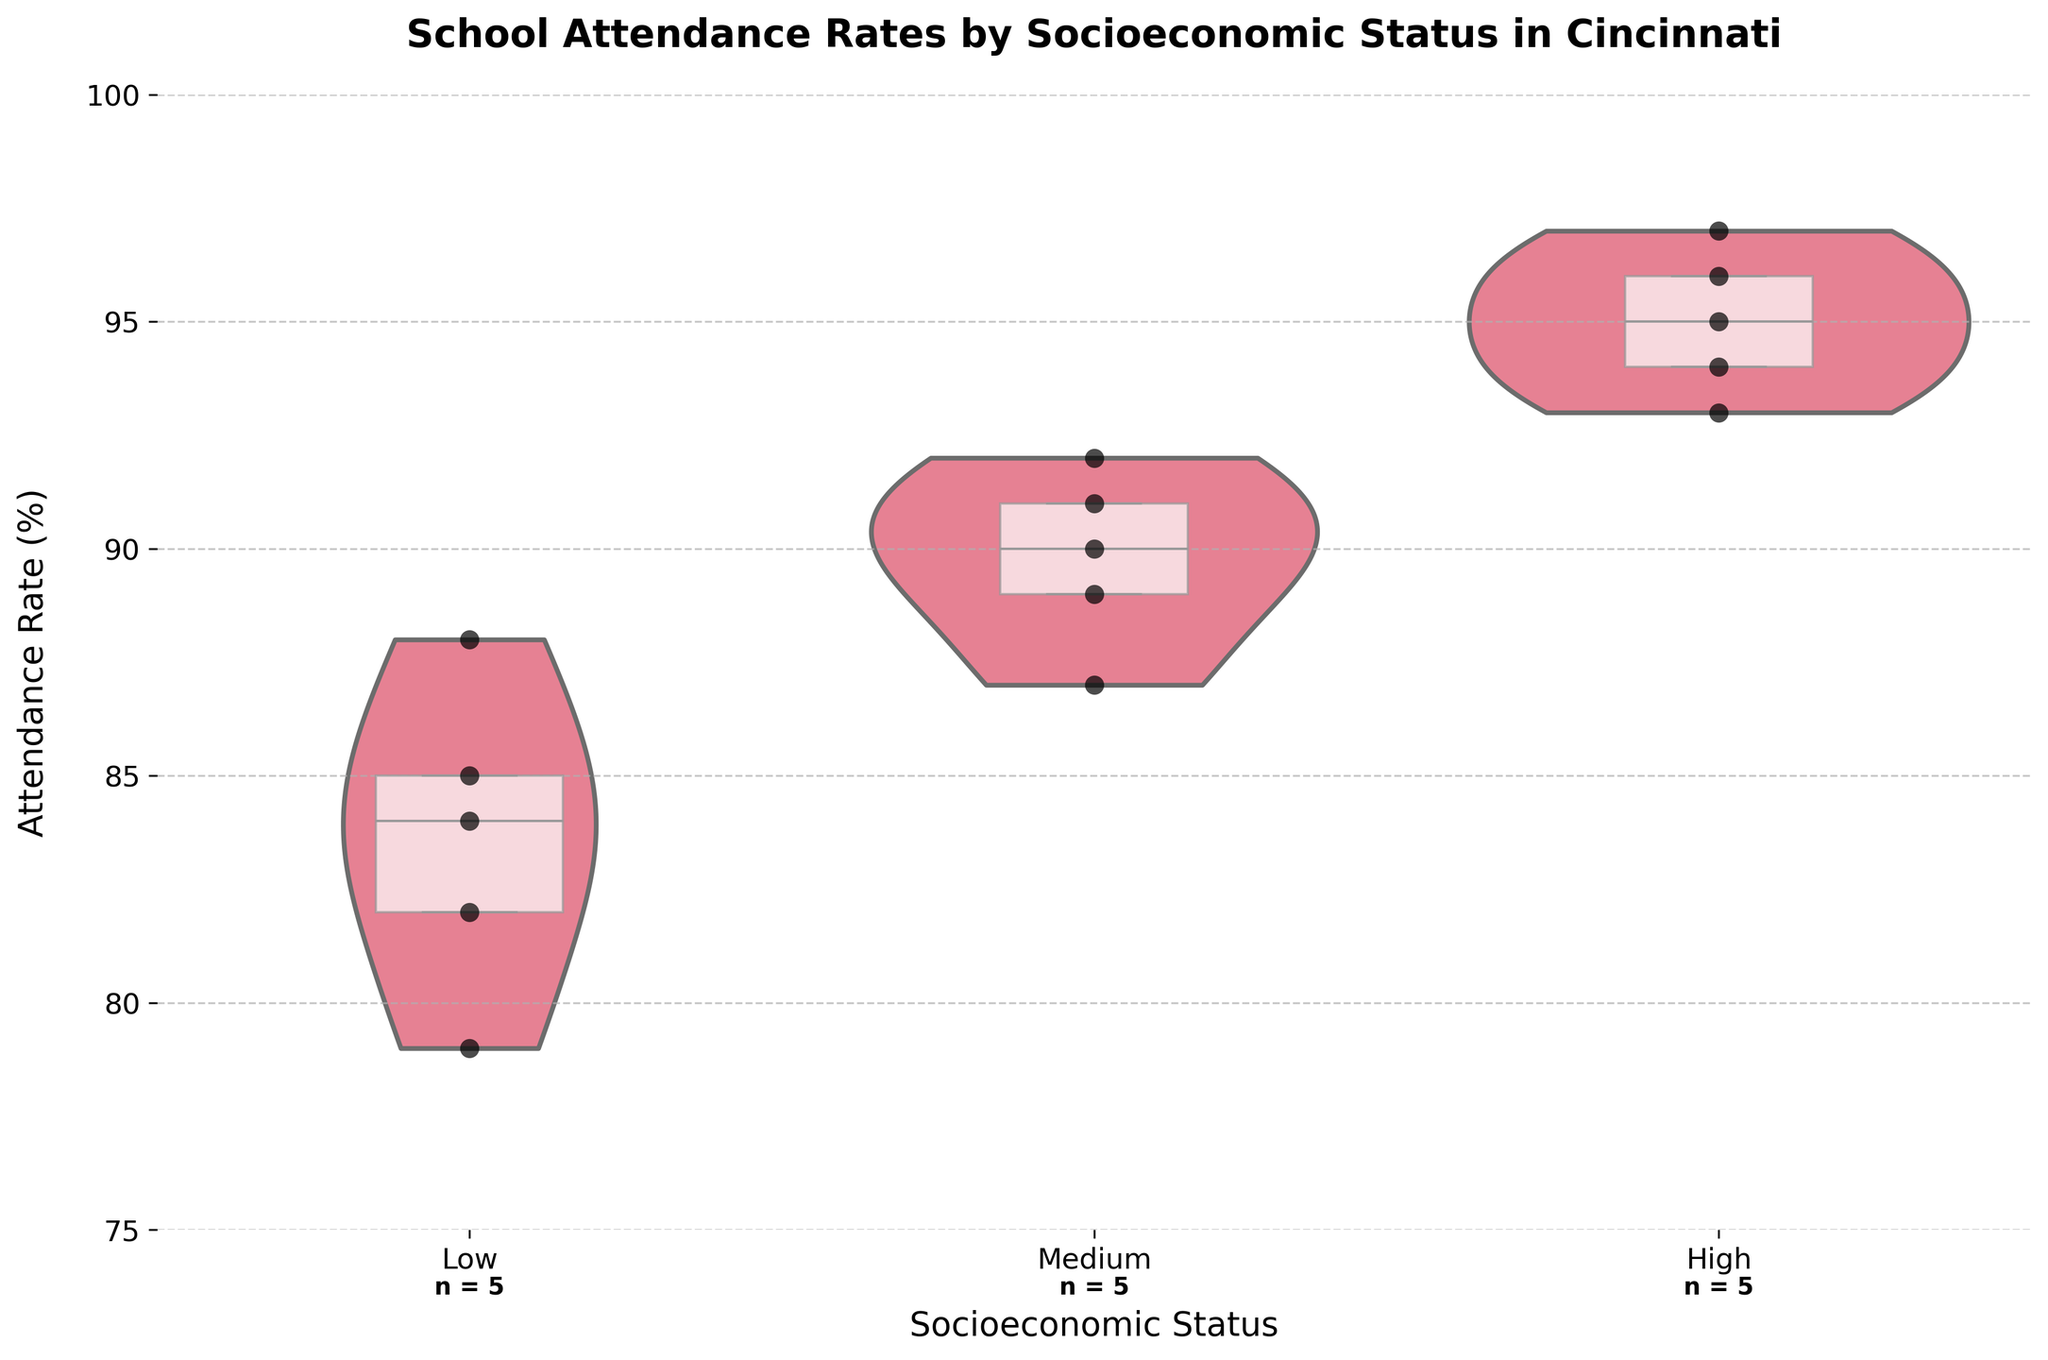What is the title of the figure? The title of the figure is displayed at the top and provides a summary of what the chart is about.
Answer: School Attendance Rates by Socioeconomic Status in Cincinnati What are the three categories of socioeconomic status shown on the x-axis? The x-axis categorizes the schools based on their socioeconomic status.
Answer: Low, Medium, High Which socioeconomic status group has the highest median attendance rate? The median value in each box plot is indicated by the white line inside the box.
Answer: High What is the range of attendance rates for the Low socioeconomic status group? The range can be determined by looking at the extent of the violin plot for the Low group.
Answer: 79% to 88% How many schools are represented in the Medium socioeconomic status group? The number of schools in each socioeconomic status group is written below the x-axis labels.
Answer: 5 Does the High socioeconomic status group have any outliers in attendance rates? Outliers would be represented by points outside the whiskers of the box, but none are present in the High group.
Answer: No Which socioeconomic status group shows the widest spread in attendance rates? The spread of the attendance rates is represented by the width of the violin plot.
Answer: Low What is the average attendance rate of schools in the Medium socioeconomic status group? Sum up the attendance rates of all schools in the Medium group and divide by the number of schools. (92 + 90 + 89 + 87 + 91) / 5 = 89.8%
Answer: 89.8% Comparing the Low and High socioeconomic status groups, which one has higher variability in attendance rates? Variability is higher when the violin plot is wider and the box plot is taller.
Answer: Low How does the attendance rate of Roll Hill Academy compare to the median attendance rate of its socioeconomic status group? Find the position of Roll Hill Academy's attendance rate within the violin and box plot of the Low group.
Answer: Lower 